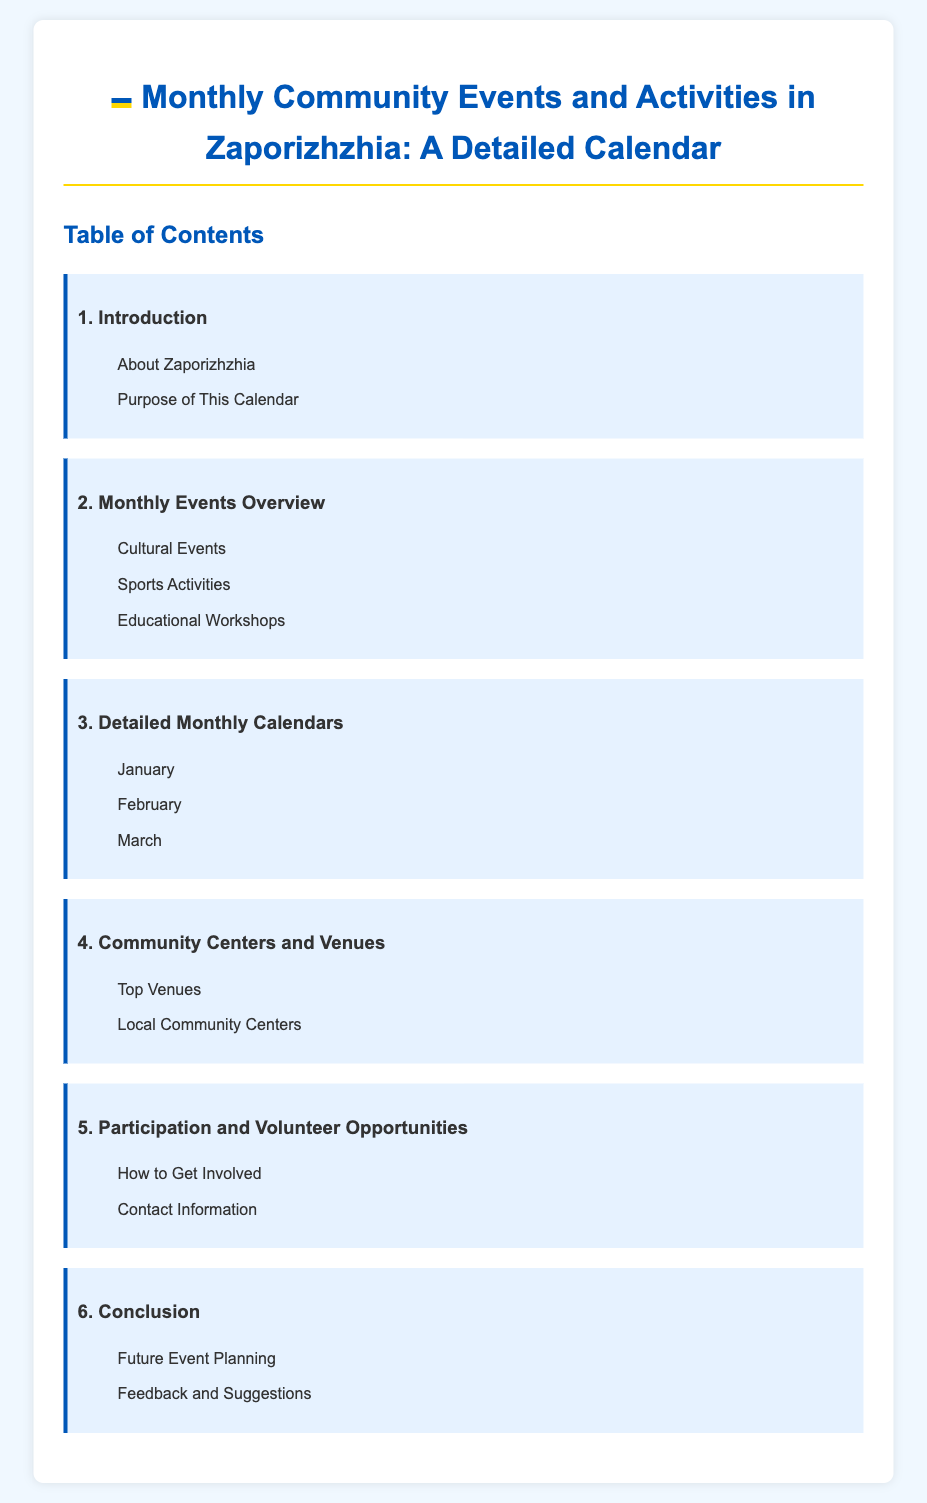What is the title of the document? The title provides the main topic and is mentioned in the `<title>` tag.
Answer: Monthly Community Events and Activities in Zaporizhzhia: A Detailed Calendar How many sections are in the Table of Contents? The number of sections can be determined by counting the main headings in the Table of Contents.
Answer: 6 What month is listed first in the detailed calendars? The first month mentioned in the detailed monthly calendars is noted in the list under "Detailed Monthly Calendars".
Answer: January Which section contains information about community centers? The section that discusses community centers is indicated in the Table of Contents.
Answer: Community Centers and Venues What is one type of event included in the monthly events overview? A glance at the overview shows categories that are part of the events.
Answer: Cultural Events Where can I find contact information for participation? The location of contact information can be identified in the Table of Contents.
Answer: Participation and Volunteer Opportunities What is the purpose of the calendar? The purpose is outlined in the introduction section.
Answer: Purpose of This Calendar How can residents volunteer for community events? The method of getting involved is specified in one of the subsections.
Answer: How to Get Involved 